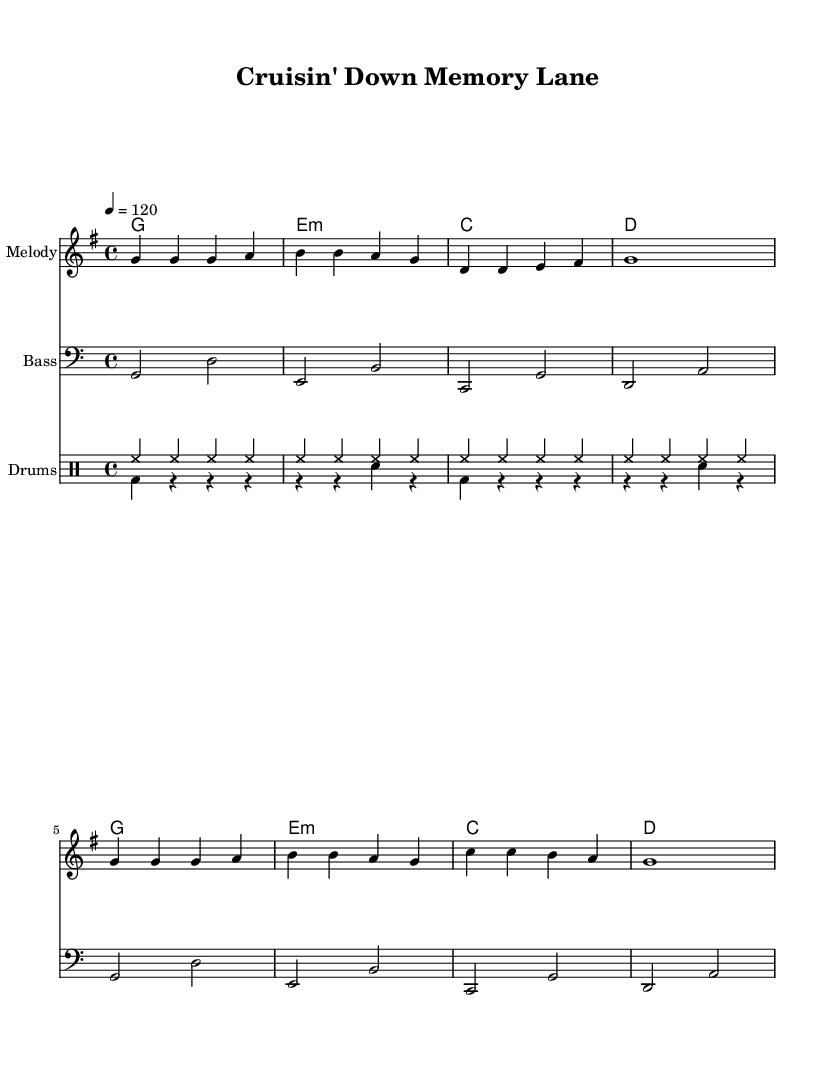What is the key signature of this music? The key signature is G major, which has one sharp (F#). In the global section of the code, we see `\key g \major`, indicating G major.
Answer: G major What is the time signature of this music? The time signature is 4/4, which allows four beats per measure. In the global section of the code, we see `\time 4/4`, confirming this.
Answer: 4/4 What is the tempo marking for this piece? The tempo marking is 120 beats per minute. This is indicated in the global section by `\tempo 4 = 120`.
Answer: 120 What is the chord progression for the harmonies? The chord progression consists of G, E minor, C, and D. These are the chords listed under the `\harmonies` section and confirm the structure repeated in the music.
Answer: G, E minor, C, D How many different drum voices are utilized in the score? Two different drum voices are used, indicated by `\new DrumVoice` for both the `drumsUp` and `drumsDown` sections.
Answer: 2 What rhythmic pattern does the bass line follow? The bass line primarily follows a double note pattern in each measure, alternating between roots and fifths of the chords above. In the bass section, we observe pairs of notes forming this structure.
Answer: Alternating roots and fifths 